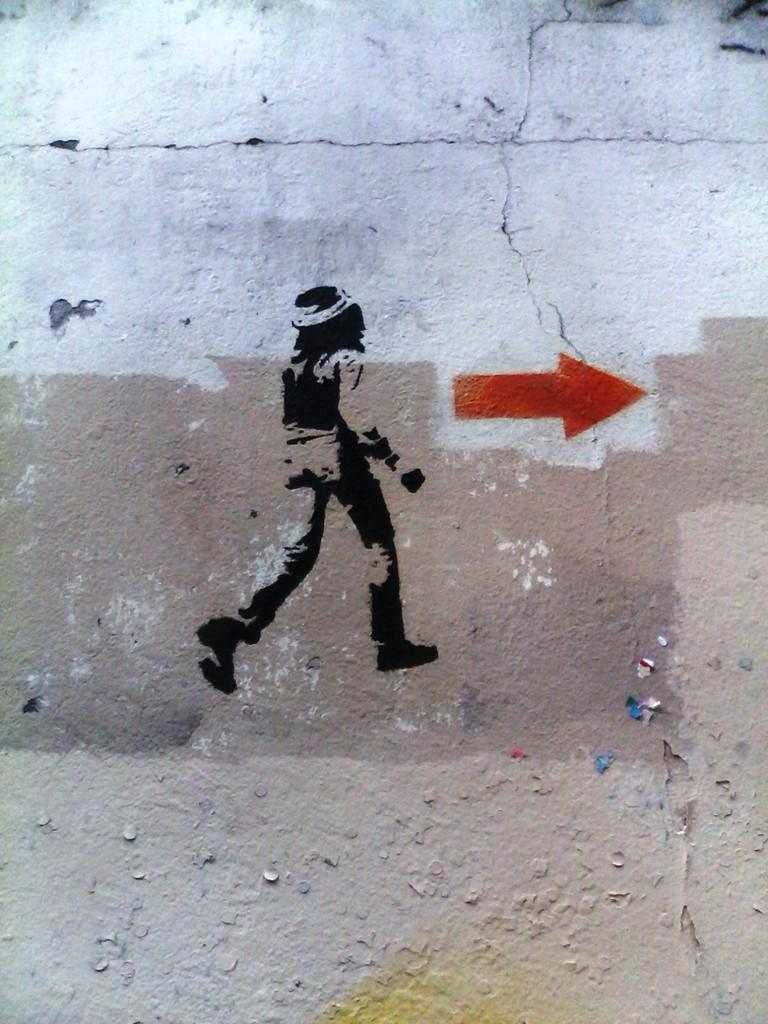What is depicted on the small painting on the white wall? There is a small painting of a man on the white wall. Is there any additional marking or symbol near the painting? Yes, there is a red arrow mark beside the painting. What word is being carried by the wind in the image? There is no reference to a word or wind in the image; it only features a small painting of a man and a red arrow mark. 